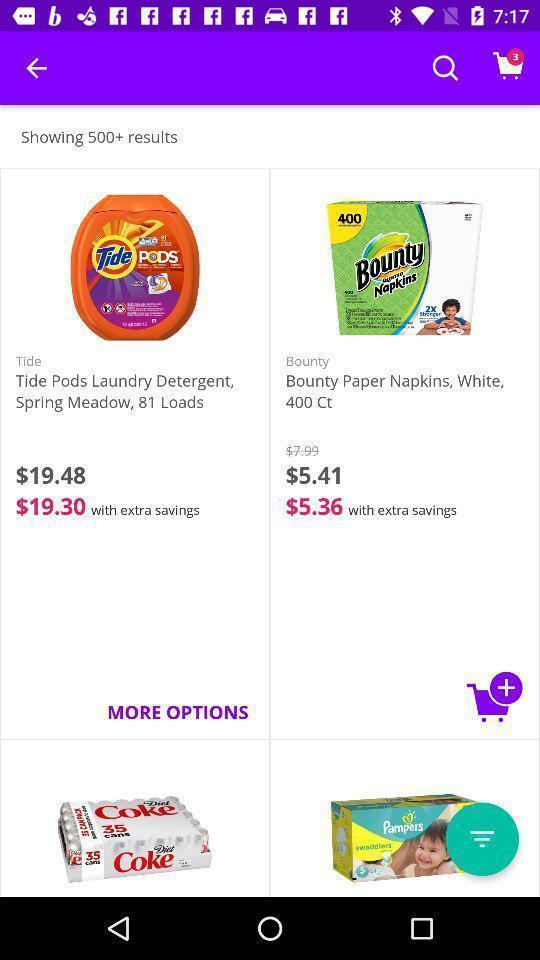Provide a textual representation of this image. Screen shows products for sale in the shopping app. 